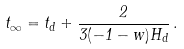Convert formula to latex. <formula><loc_0><loc_0><loc_500><loc_500>t _ { \infty } = t _ { d } + \frac { 2 } { 3 ( - 1 - w ) H _ { d } } \, . \,</formula> 